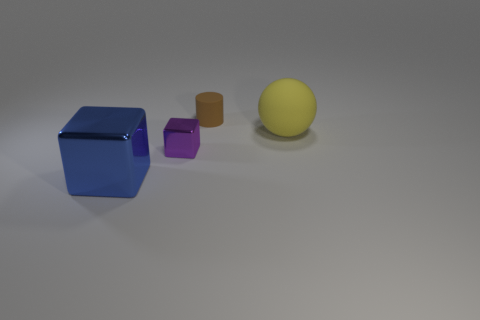Is the shape of the purple metallic thing the same as the blue object?
Provide a short and direct response. Yes. How many brown matte things are in front of the rubber object that is on the left side of the large yellow matte object?
Ensure brevity in your answer.  0. There is a brown thing that is the same material as the large sphere; what shape is it?
Offer a terse response. Cylinder. What number of yellow objects are either matte objects or metal cubes?
Provide a short and direct response. 1. Are there any tiny metallic cubes that are on the right side of the metal object that is right of the metallic object that is to the left of the tiny purple metal object?
Ensure brevity in your answer.  No. Is the number of small green objects less than the number of small brown matte cylinders?
Offer a terse response. Yes. Is the shape of the metallic object that is right of the large blue block the same as  the blue thing?
Give a very brief answer. Yes. Are any large blue cylinders visible?
Give a very brief answer. No. The shiny cube to the right of the large object to the left of the small thing that is behind the large yellow sphere is what color?
Provide a short and direct response. Purple. Is the number of blue cubes behind the purple shiny thing the same as the number of small brown cylinders that are behind the small matte thing?
Your answer should be compact. Yes. 